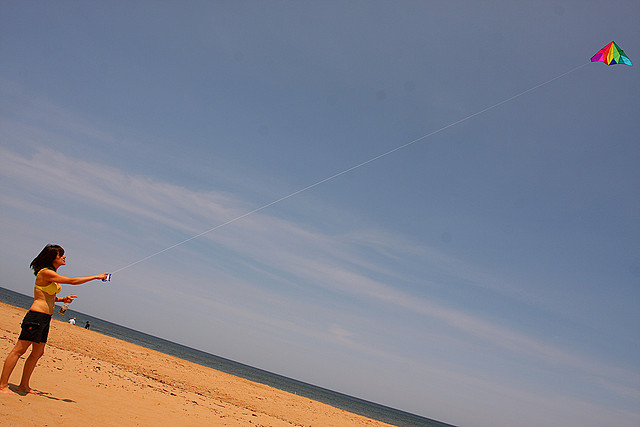<image>What pattern is the this person's shorts? I am not sure. The pattern of this person's shorts can be solid or plain. What pattern is the this person's shorts? I am not sure what pattern is on the person's shorts. It can be either solid or plain. 